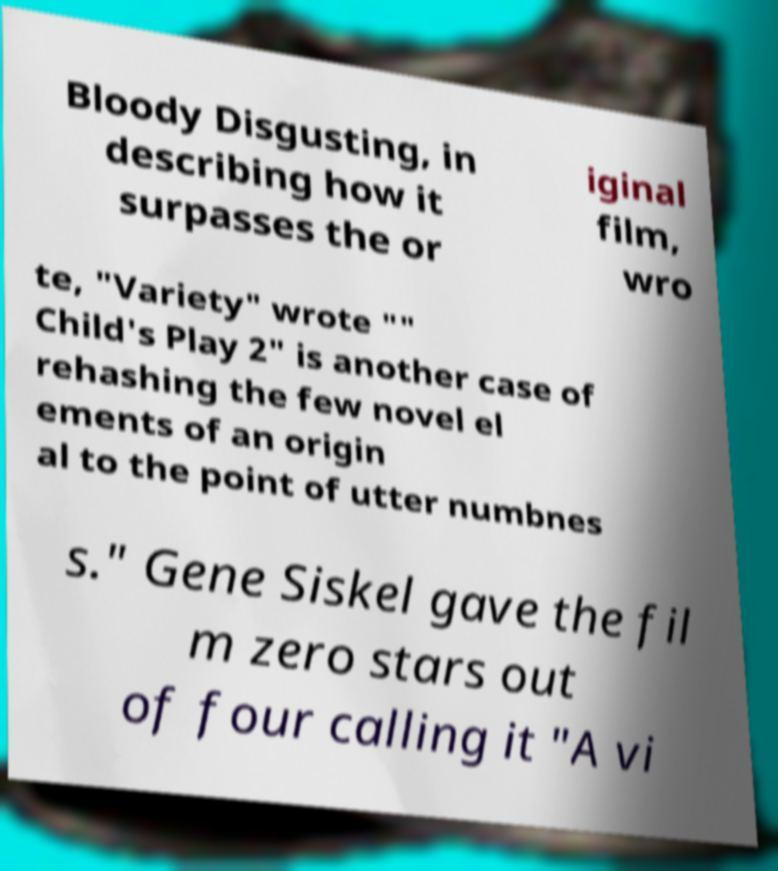What messages or text are displayed in this image? I need them in a readable, typed format. Bloody Disgusting, in describing how it surpasses the or iginal film, wro te, "Variety" wrote "" Child's Play 2" is another case of rehashing the few novel el ements of an origin al to the point of utter numbnes s." Gene Siskel gave the fil m zero stars out of four calling it "A vi 